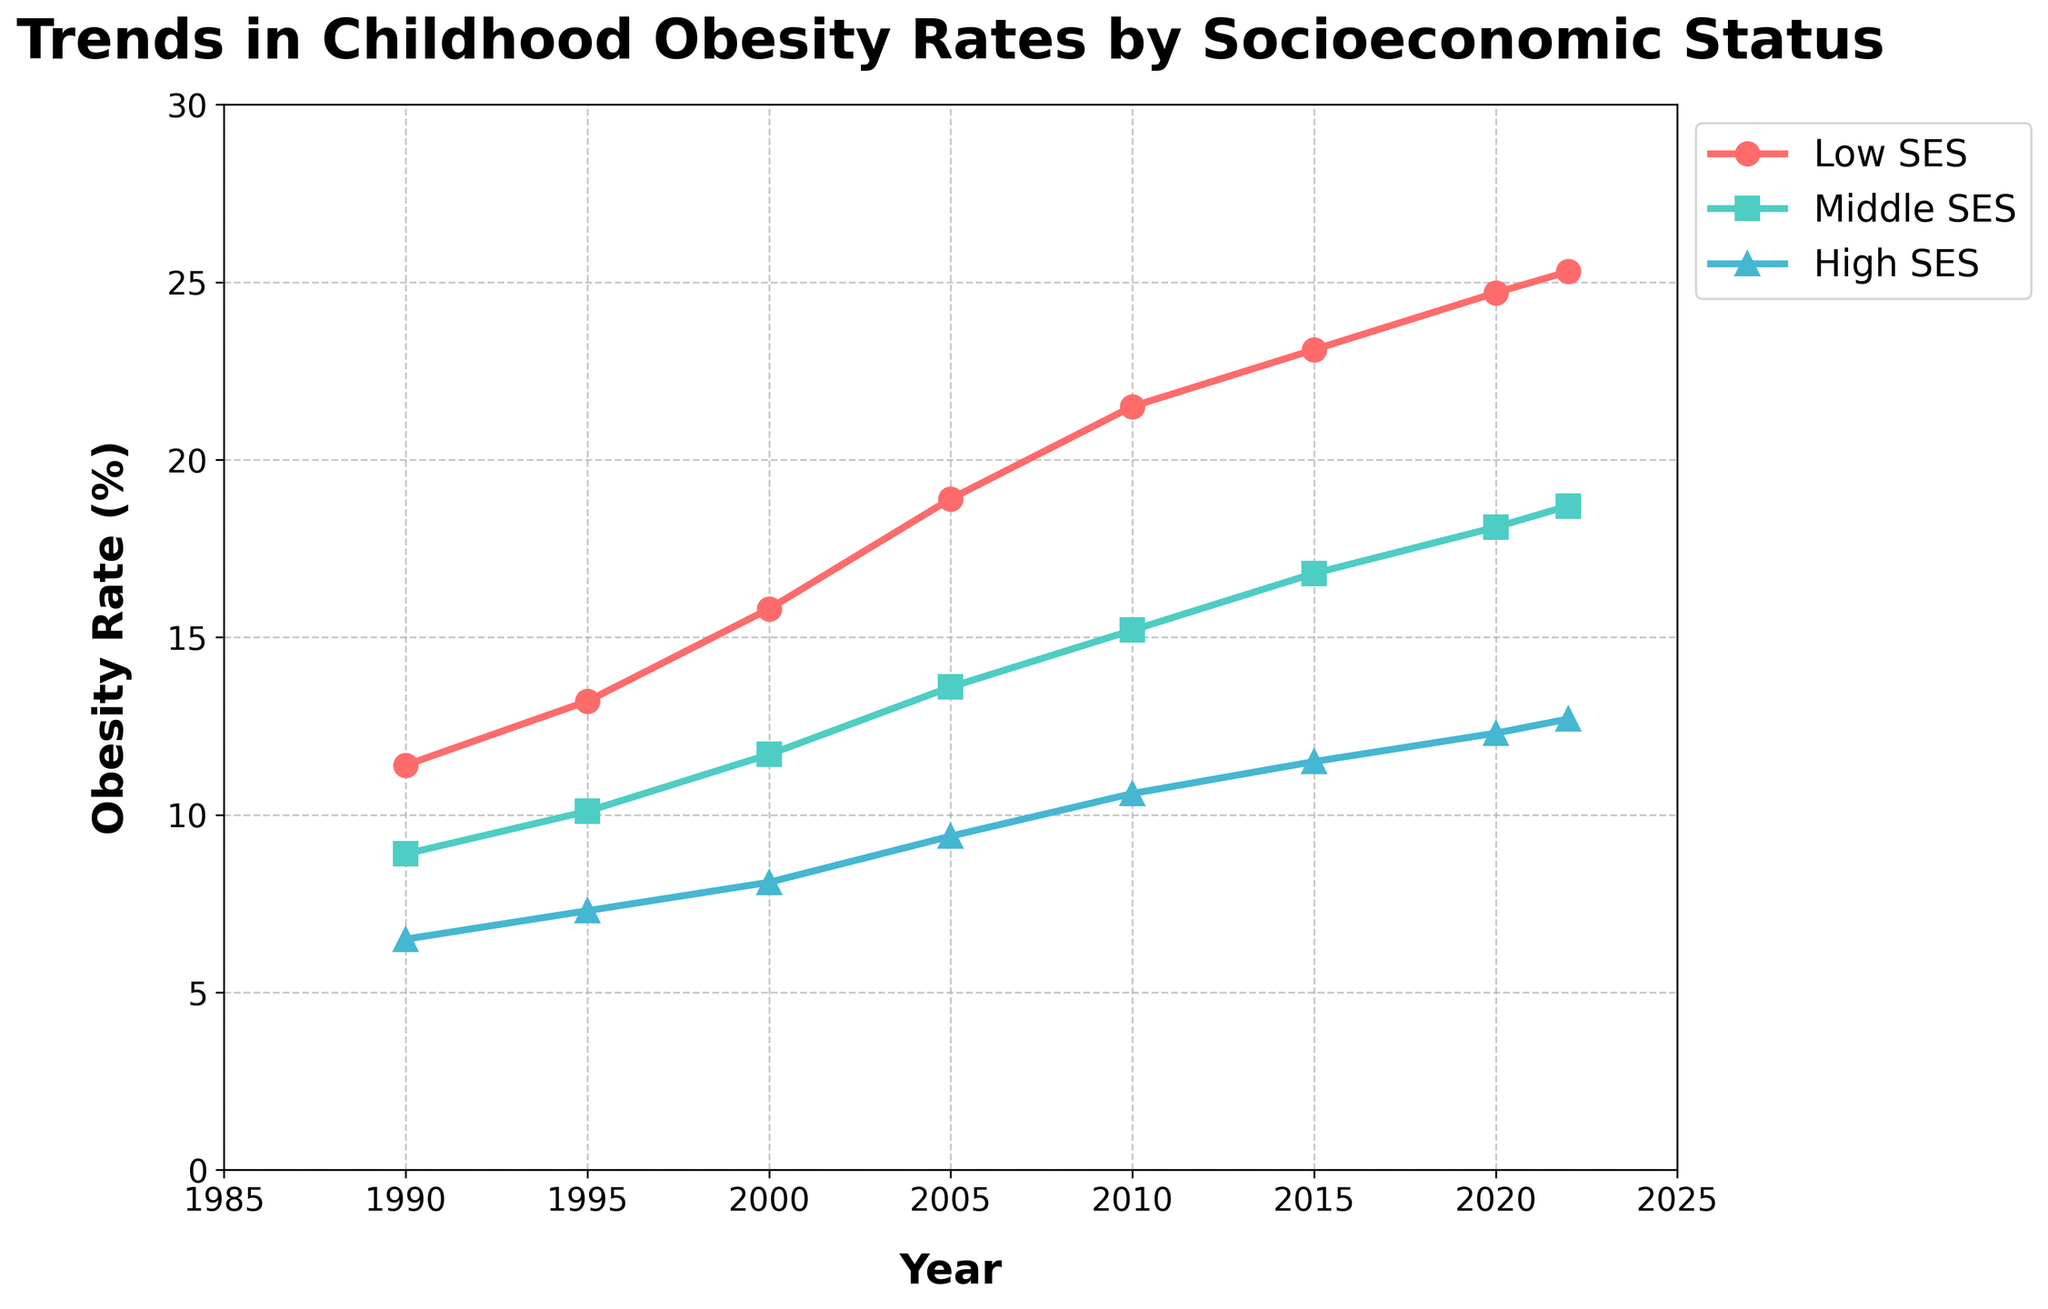What is the overall trend in childhood obesity rates across all socioeconomic statuses from 1990 to 2022? Over time, all three socioeconomic status (SES) groups (Low, Middle, and High) show an increasing trend in childhood obesity rates. All lines in the chart rise from 1990 to 2022.
Answer: Increasing trend Which socioeconomic status group had the highest childhood obesity rate in 2022? In 2022, the group with the highest line on the chart is the Low SES group.
Answer: Low SES What is the difference in childhood obesity rates between the Low SES and High SES groups in 2022? The childhood obesity rate in 2022 for the Low SES group is 25.3%, and for the High SES group, it is 12.7%. The difference is 25.3% - 12.7%.
Answer: 12.6% Which year shows the most significant increase in childhood obesity rates for the Middle SES group compared to the previous year? By examining the slope of the Middle SES line between each year, the steepest increase is observed between 2000 and 2005, where the obesity rates go from 11.7% to 13.6%.
Answer: 2000-2005 What is the average childhood obesity rate for the High SES group over the full period (1990 to 2022)? The average rate is calculated by summing all the values from 1990, 1995, 2000, 2005, 2010, 2015, 2020, and 2022 and then dividing by the number of data points: (6.5 + 7.3 + 8.1 + 9.4 + 10.6 + 11.5 + 12.3 + 12.7) / 8 = 9.675%.
Answer: 9.675% By how much did childhood obesity rates in the Low SES group increase from 1990 to 2022? The rate in the Low SES group increased from 11.4% in 1990 to 25.3% in 2022. The increase is calculated by subtracting the earlier value from the later value: 25.3% - 11.4%.
Answer: 13.9% During which period did the High SES group's childhood obesity rate cross 10%? The line for the High SES group crosses the 10% mark between 2005 and 2010, indicating it happened during this period.
Answer: 2005-2010 